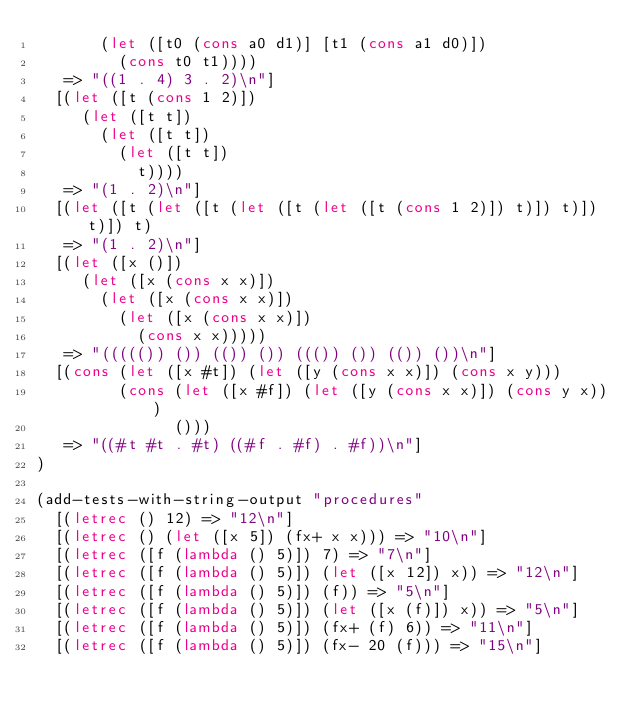<code> <loc_0><loc_0><loc_500><loc_500><_Scheme_>       (let ([t0 (cons a0 d1)] [t1 (cons a1 d0)])
         (cons t0 t1))))
   => "((1 . 4) 3 . 2)\n"]
  [(let ([t (cons 1 2)])
     (let ([t t])
       (let ([t t])
         (let ([t t])
           t))))
   => "(1 . 2)\n"]
  [(let ([t (let ([t (let ([t (let ([t (cons 1 2)]) t)]) t)]) t)]) t)
   => "(1 . 2)\n"]
  [(let ([x ()])
     (let ([x (cons x x)])
       (let ([x (cons x x)])
         (let ([x (cons x x)])
           (cons x x)))))
   => "((((()) ()) (()) ()) ((()) ()) (()) ())\n"]
  [(cons (let ([x #t]) (let ([y (cons x x)]) (cons x y)))
         (cons (let ([x #f]) (let ([y (cons x x)]) (cons y x))) 
               ())) 
   => "((#t #t . #t) ((#f . #f) . #f))\n"]
)

(add-tests-with-string-output "procedures"
  [(letrec () 12) => "12\n"]
  [(letrec () (let ([x 5]) (fx+ x x))) => "10\n"]
  [(letrec ([f (lambda () 5)]) 7) => "7\n"]
  [(letrec ([f (lambda () 5)]) (let ([x 12]) x)) => "12\n"]
  [(letrec ([f (lambda () 5)]) (f)) => "5\n"]
  [(letrec ([f (lambda () 5)]) (let ([x (f)]) x)) => "5\n"]
  [(letrec ([f (lambda () 5)]) (fx+ (f) 6)) => "11\n"]
  [(letrec ([f (lambda () 5)]) (fx- 20 (f))) => "15\n"]</code> 